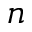<formula> <loc_0><loc_0><loc_500><loc_500>n</formula> 